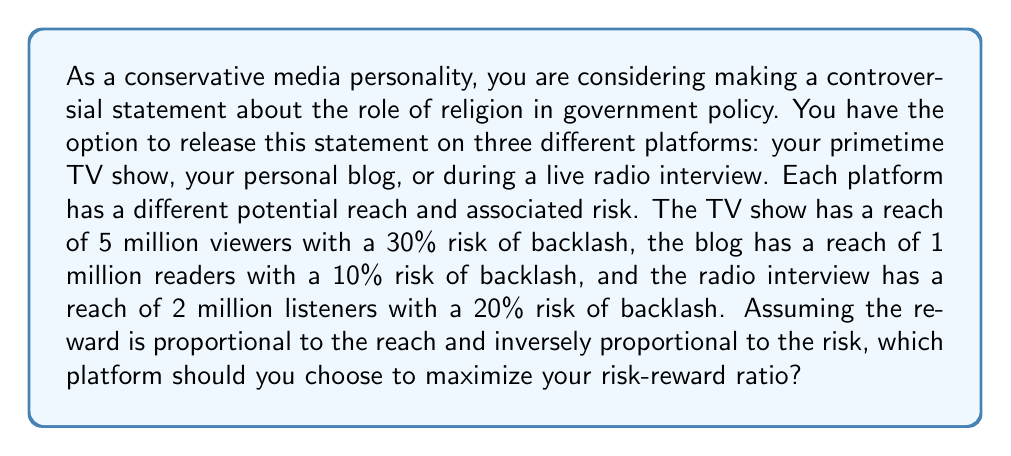Provide a solution to this math problem. To solve this problem, we need to calculate the risk-reward ratio for each platform and compare them. The risk-reward ratio can be expressed as:

$$ \text{Risk-Reward Ratio} = \frac{\text{Reach}}{\text{Risk}} $$

Let's calculate this for each platform:

1. TV Show:
   $$ \text{Risk-Reward Ratio}_{\text{TV}} = \frac{5,000,000}{0.30} = 16,666,667 $$

2. Personal Blog:
   $$ \text{Risk-Reward Ratio}_{\text{Blog}} = \frac{1,000,000}{0.10} = 10,000,000 $$

3. Radio Interview:
   $$ \text{Risk-Reward Ratio}_{\text{Radio}} = \frac{2,000,000}{0.20} = 10,000,000 $$

Comparing these ratios, we can see that the TV show has the highest risk-reward ratio, making it the optimal choice for maximizing impact while considering the associated risks.

This aligns with the persona of a conservative media personality who believes in the intertwining of religion and politics, as it provides the largest platform to share views on the role of religion in government policy, despite the higher risk of backlash.
Answer: The TV show platform, with a risk-reward ratio of 16,666,667, should be chosen to maximize the risk-reward ratio. 